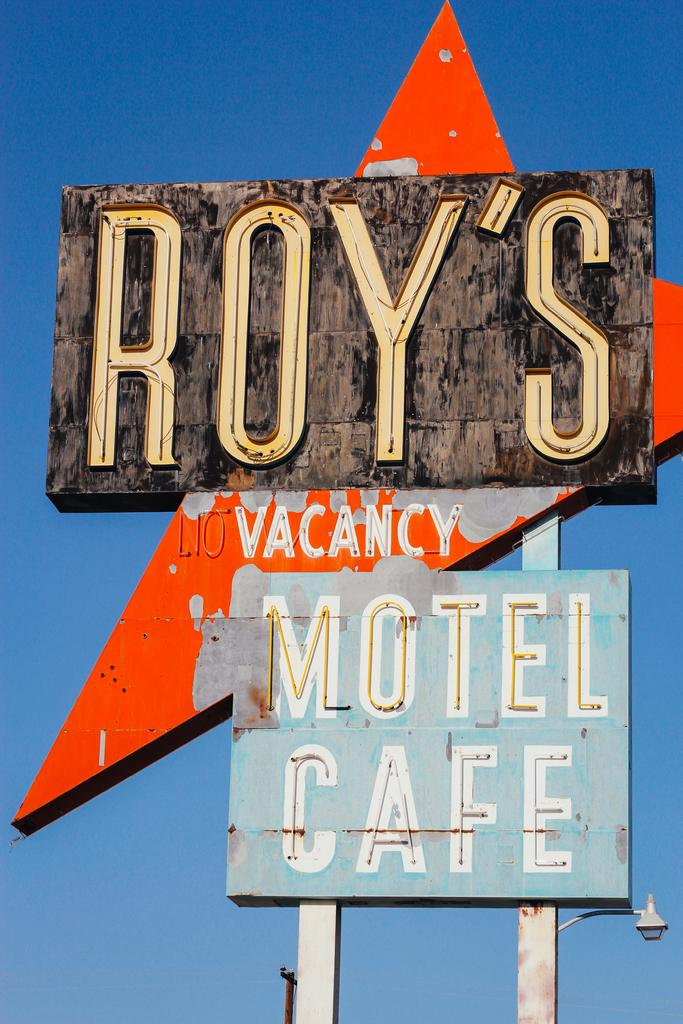What is on the board that is visible in the image? There is text on the board in the image. What can be seen in the image besides the board? Light is visible in the image. What color is the sky in the background of the image? The sky is blue in the background of the image. How many ants are crawling on the board in the image? There are no ants present in the image. What type of goat can be seen grazing in the background of the image? There is no goat present in the image; the background features a blue sky. 